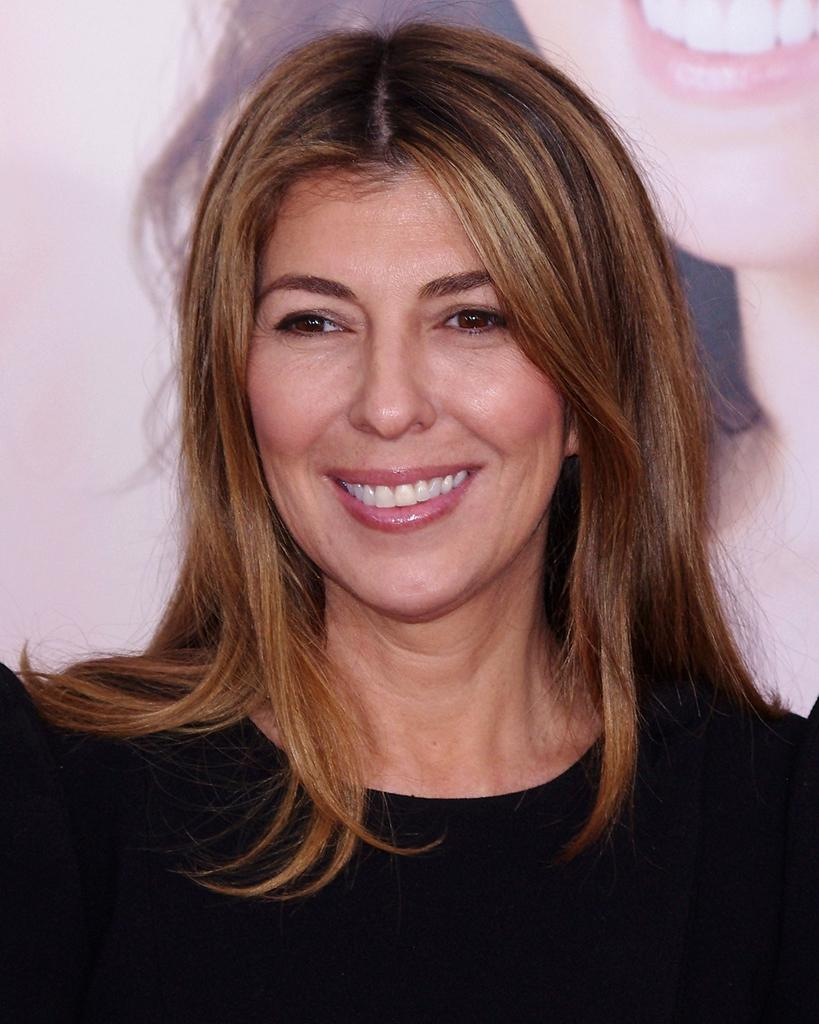Who is the main subject in the image? There is a lady in the center of the image. What is the lady wearing? The lady is wearing a black dress. What can be seen in the background of the image? There is a banner in the background of the image. What is depicted on the banner? The banner has a depiction of a lady. What type of caption is written below the lady on the banner? There is no caption written below the lady on the banner in the image. Can you see any frogs in the image? There are no frogs present in the image. 